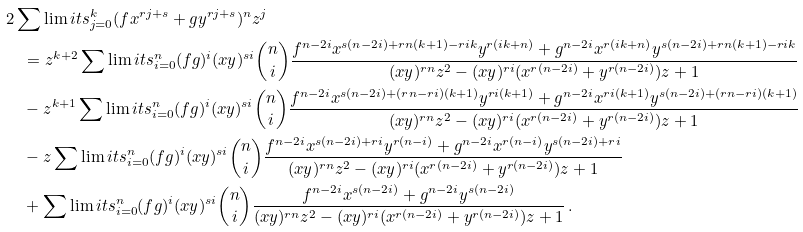<formula> <loc_0><loc_0><loc_500><loc_500>& 2 \sum \lim i t s _ { j = 0 } ^ { k } { ( f x ^ { r j + s } + g y ^ { r j + s } ) ^ { n } z ^ { j } } \\ & \quad = z ^ { k + 2 } \sum \lim i t s _ { i = 0 } ^ { n } { ( f g ) ^ { i } ( x y ) ^ { s i } \binom { n } { i } \frac { { f ^ { n - 2 i } x ^ { s ( n - 2 i ) + r n ( k + 1 ) - r i k } y ^ { r ( i k + n ) } + g ^ { n - 2 i } x ^ { r ( i k + n ) } y ^ { s ( n - 2 i ) + r n ( k + 1 ) - r i k } } } { { ( x y ) ^ { r n } z ^ { 2 } - ( x y ) ^ { r i } ( x ^ { r ( n - 2 i ) } + y ^ { r ( n - 2 i ) } ) z + 1 } } } \\ & \quad - z ^ { k + 1 } \sum \lim i t s _ { i = 0 } ^ { n } { ( f g ) ^ { i } ( x y ) ^ { s i } \binom { n } { i } \frac { { f ^ { n - 2 i } x ^ { s ( n - 2 i ) + ( r n - r i ) ( k + 1 ) } y ^ { r i ( k + 1 ) } + g ^ { n - 2 i } x ^ { r i ( k + 1 ) } y ^ { s ( n - 2 i ) + ( r n - r i ) ( k + 1 ) } } } { { ( x y ) ^ { r n } z ^ { 2 } - ( x y ) ^ { r i } ( x ^ { r ( n - 2 i ) } + y ^ { r ( n - 2 i ) } ) z + 1 } } } \\ & \quad - z \sum \lim i t s _ { i = 0 } ^ { n } { ( f g ) ^ { i } ( x y ) ^ { s i } \binom { n } { i } \frac { { f ^ { n - 2 i } x ^ { s ( n - 2 i ) + r i } y ^ { r ( n - i ) } + g ^ { n - 2 i } x ^ { r ( n - i ) } y ^ { s ( n - 2 i ) + r i } } } { { ( x y ) ^ { r n } z ^ { 2 } - ( x y ) ^ { r i } ( x ^ { r ( n - 2 i ) } + y ^ { r ( n - 2 i ) } ) z + 1 } } } \\ & \quad + \sum \lim i t s _ { i = 0 } ^ { n } { ( f g ) ^ { i } ( x y ) ^ { s i } \binom { n } { i } \frac { { f ^ { n - 2 i } x ^ { s ( n - 2 i ) } + g ^ { n - 2 i } y ^ { s ( n - 2 i ) } } } { { ( x y ) ^ { r n } z ^ { 2 } - ( x y ) ^ { r i } ( x ^ { r ( n - 2 i ) } + y ^ { r ( n - 2 i ) } ) z + 1 } } } \, .</formula> 